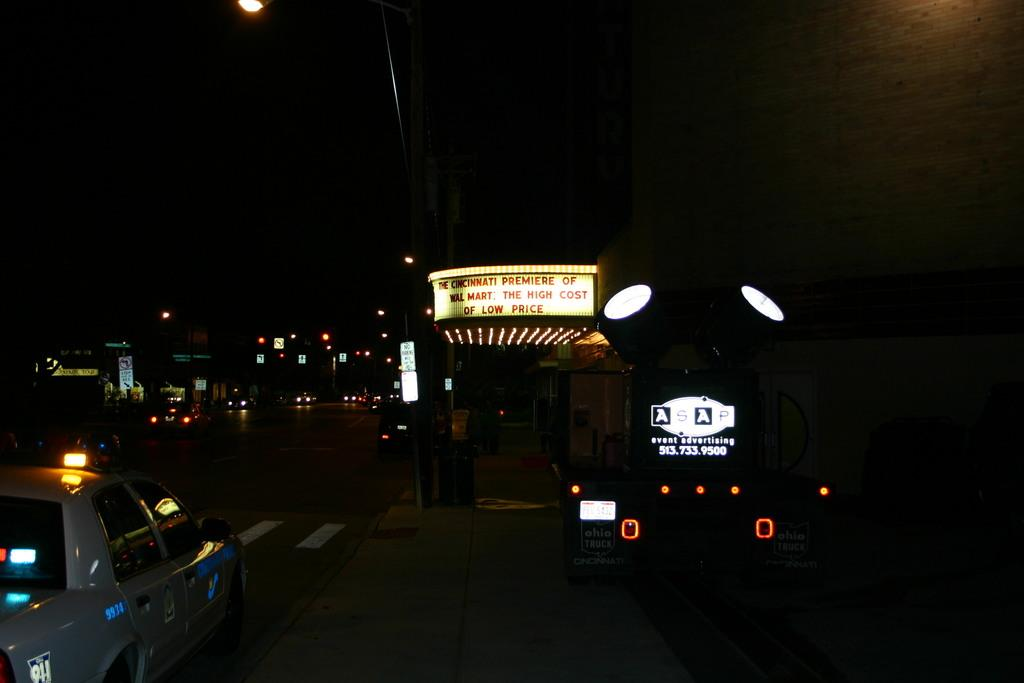<image>
Relay a brief, clear account of the picture shown. A sign saying The Cincinnati Premiere of WalMart. 